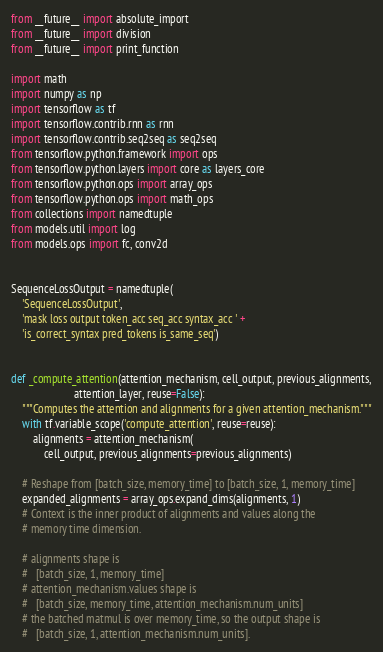Convert code to text. <code><loc_0><loc_0><loc_500><loc_500><_Python_>from __future__ import absolute_import
from __future__ import division
from __future__ import print_function

import math
import numpy as np
import tensorflow as tf
import tensorflow.contrib.rnn as rnn
import tensorflow.contrib.seq2seq as seq2seq
from tensorflow.python.framework import ops
from tensorflow.python.layers import core as layers_core
from tensorflow.python.ops import array_ops
from tensorflow.python.ops import math_ops
from collections import namedtuple
from models.util import log
from models.ops import fc, conv2d


SequenceLossOutput = namedtuple(
    'SequenceLossOutput',
    'mask loss output token_acc seq_acc syntax_acc ' +
    'is_correct_syntax pred_tokens is_same_seq')


def _compute_attention(attention_mechanism, cell_output, previous_alignments,
                       attention_layer, reuse=False):
    """Computes the attention and alignments for a given attention_mechanism."""
    with tf.variable_scope('compute_attention', reuse=reuse):
        alignments = attention_mechanism(
            cell_output, previous_alignments=previous_alignments)

    # Reshape from [batch_size, memory_time] to [batch_size, 1, memory_time]
    expanded_alignments = array_ops.expand_dims(alignments, 1)
    # Context is the inner product of alignments and values along the
    # memory time dimension.

    # alignments shape is
    #   [batch_size, 1, memory_time]
    # attention_mechanism.values shape is
    #   [batch_size, memory_time, attention_mechanism.num_units]
    # the batched matmul is over memory_time, so the output shape is
    #   [batch_size, 1, attention_mechanism.num_units].</code> 